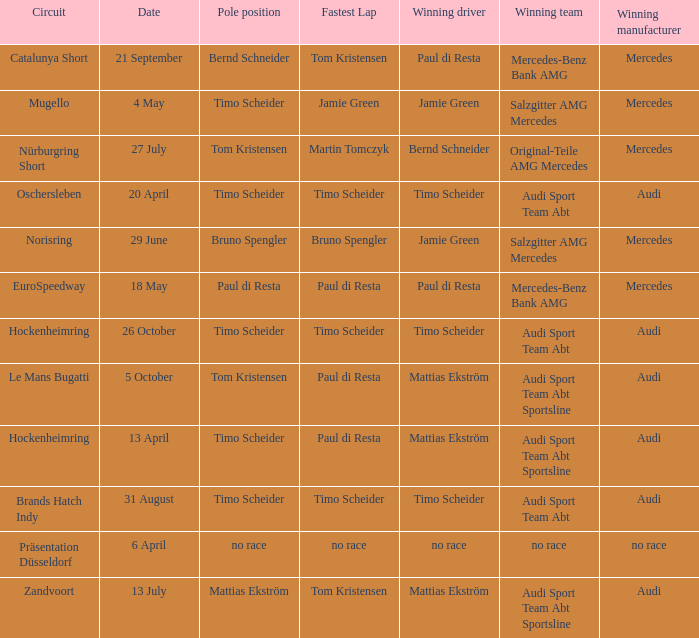What is the fastest lap of the Oschersleben circuit with Audi Sport Team ABT as the winning team? Timo Scheider. Could you parse the entire table as a dict? {'header': ['Circuit', 'Date', 'Pole position', 'Fastest Lap', 'Winning driver', 'Winning team', 'Winning manufacturer'], 'rows': [['Catalunya Short', '21 September', 'Bernd Schneider', 'Tom Kristensen', 'Paul di Resta', 'Mercedes-Benz Bank AMG', 'Mercedes'], ['Mugello', '4 May', 'Timo Scheider', 'Jamie Green', 'Jamie Green', 'Salzgitter AMG Mercedes', 'Mercedes'], ['Nürburgring Short', '27 July', 'Tom Kristensen', 'Martin Tomczyk', 'Bernd Schneider', 'Original-Teile AMG Mercedes', 'Mercedes'], ['Oschersleben', '20 April', 'Timo Scheider', 'Timo Scheider', 'Timo Scheider', 'Audi Sport Team Abt', 'Audi'], ['Norisring', '29 June', 'Bruno Spengler', 'Bruno Spengler', 'Jamie Green', 'Salzgitter AMG Mercedes', 'Mercedes'], ['EuroSpeedway', '18 May', 'Paul di Resta', 'Paul di Resta', 'Paul di Resta', 'Mercedes-Benz Bank AMG', 'Mercedes'], ['Hockenheimring', '26 October', 'Timo Scheider', 'Timo Scheider', 'Timo Scheider', 'Audi Sport Team Abt', 'Audi'], ['Le Mans Bugatti', '5 October', 'Tom Kristensen', 'Paul di Resta', 'Mattias Ekström', 'Audi Sport Team Abt Sportsline', 'Audi'], ['Hockenheimring', '13 April', 'Timo Scheider', 'Paul di Resta', 'Mattias Ekström', 'Audi Sport Team Abt Sportsline', 'Audi'], ['Brands Hatch Indy', '31 August', 'Timo Scheider', 'Timo Scheider', 'Timo Scheider', 'Audi Sport Team Abt', 'Audi'], ['Präsentation Düsseldorf', '6 April', 'no race', 'no race', 'no race', 'no race', 'no race'], ['Zandvoort', '13 July', 'Mattias Ekström', 'Tom Kristensen', 'Mattias Ekström', 'Audi Sport Team Abt Sportsline', 'Audi']]} 